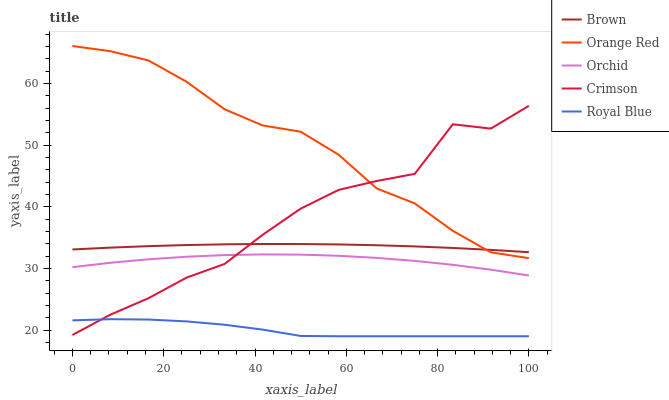Does Royal Blue have the minimum area under the curve?
Answer yes or no. Yes. Does Orange Red have the maximum area under the curve?
Answer yes or no. Yes. Does Brown have the minimum area under the curve?
Answer yes or no. No. Does Brown have the maximum area under the curve?
Answer yes or no. No. Is Brown the smoothest?
Answer yes or no. Yes. Is Crimson the roughest?
Answer yes or no. Yes. Is Orange Red the smoothest?
Answer yes or no. No. Is Orange Red the roughest?
Answer yes or no. No. Does Orange Red have the lowest value?
Answer yes or no. No. Does Brown have the highest value?
Answer yes or no. No. Is Royal Blue less than Brown?
Answer yes or no. Yes. Is Brown greater than Orchid?
Answer yes or no. Yes. Does Royal Blue intersect Brown?
Answer yes or no. No. 